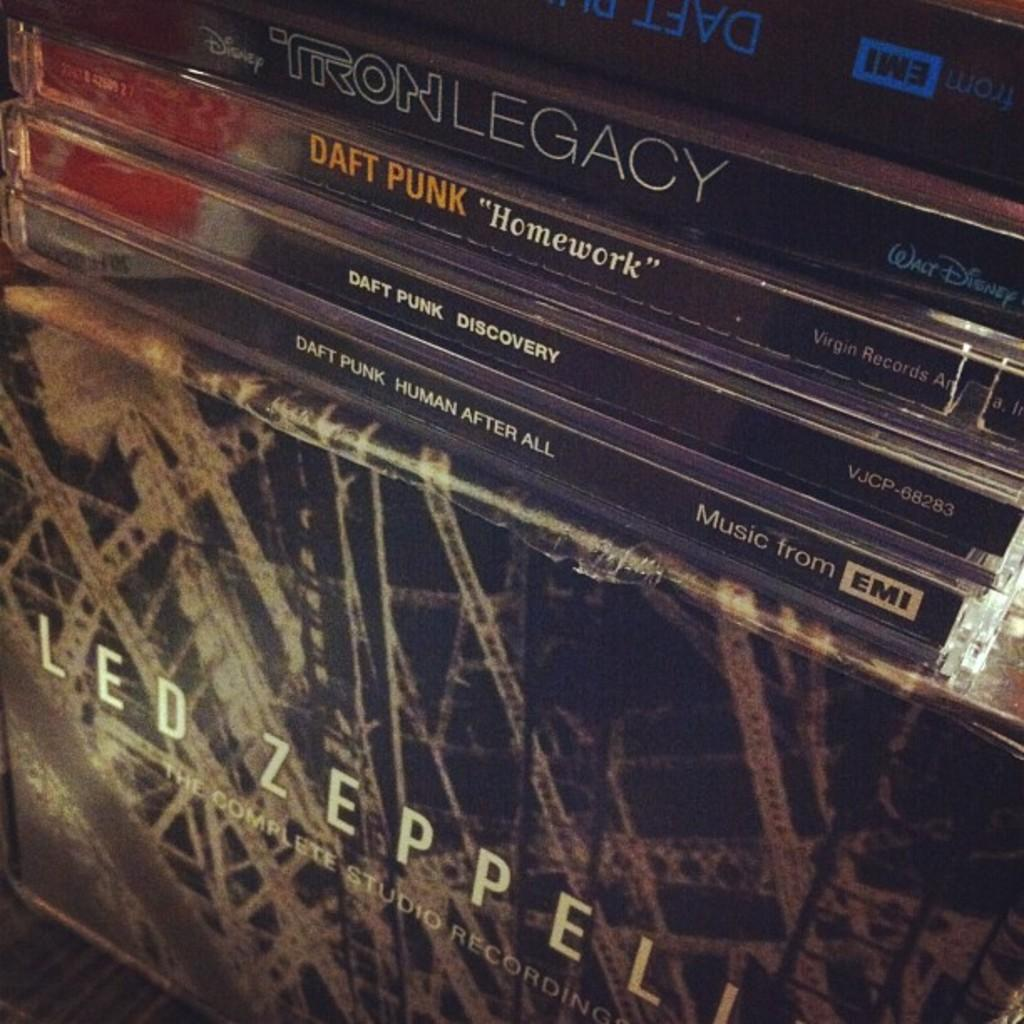<image>
Give a short and clear explanation of the subsequent image. Some Compact Discs by Daft Punk on the Led Zeppelin's album. 